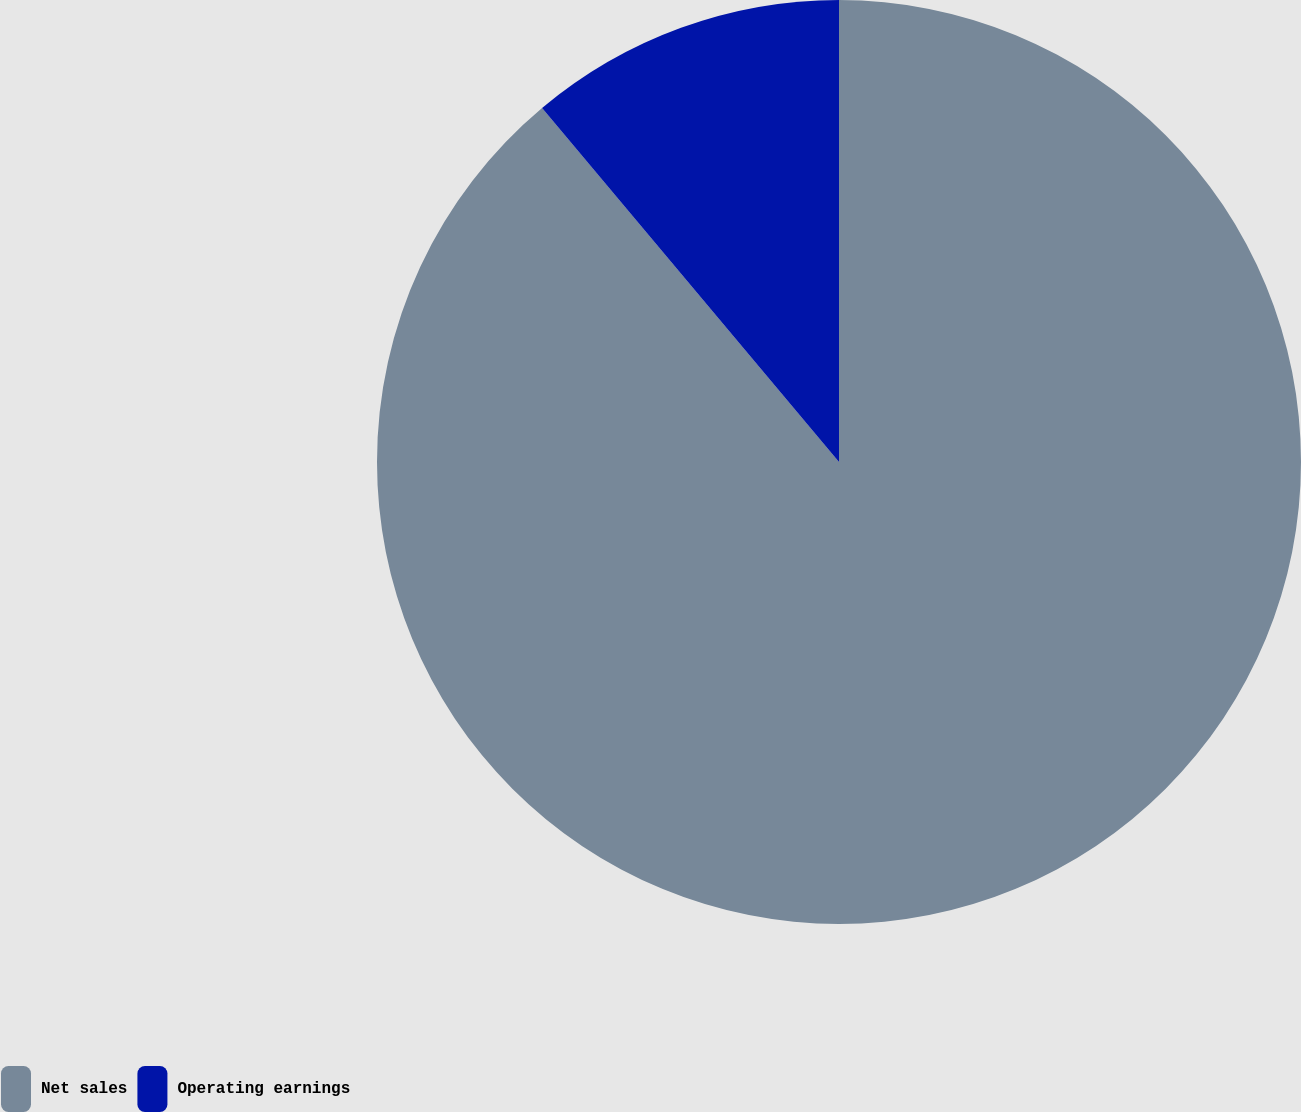Convert chart. <chart><loc_0><loc_0><loc_500><loc_500><pie_chart><fcel>Net sales<fcel>Operating earnings<nl><fcel>88.89%<fcel>11.11%<nl></chart> 